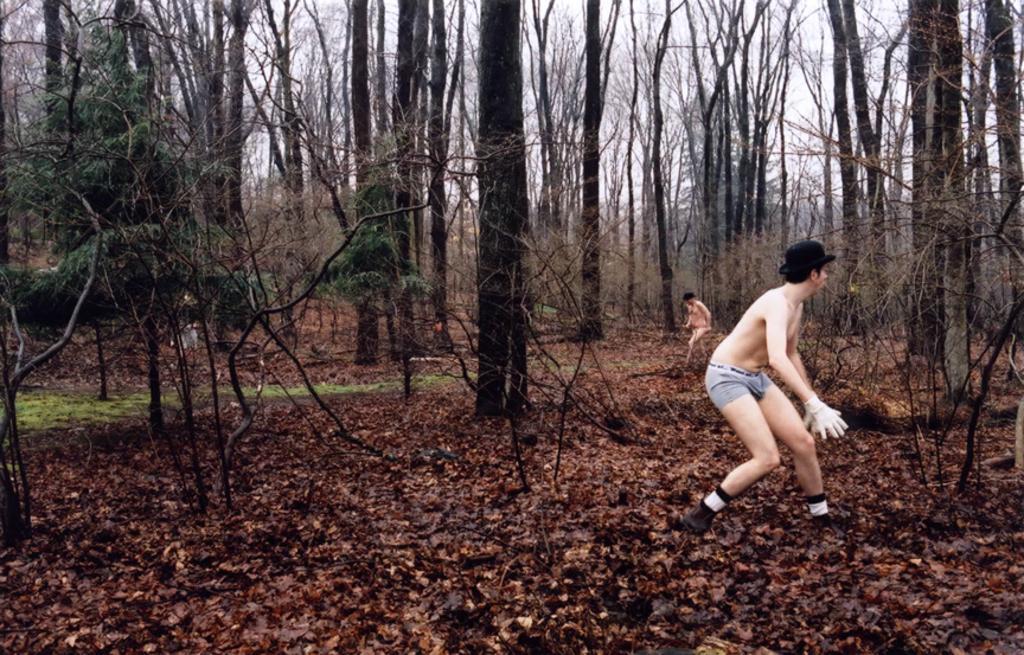How would you summarize this image in a sentence or two? In this image I can see two persons are standing on the ground. In the background I can see trees and the sky. 